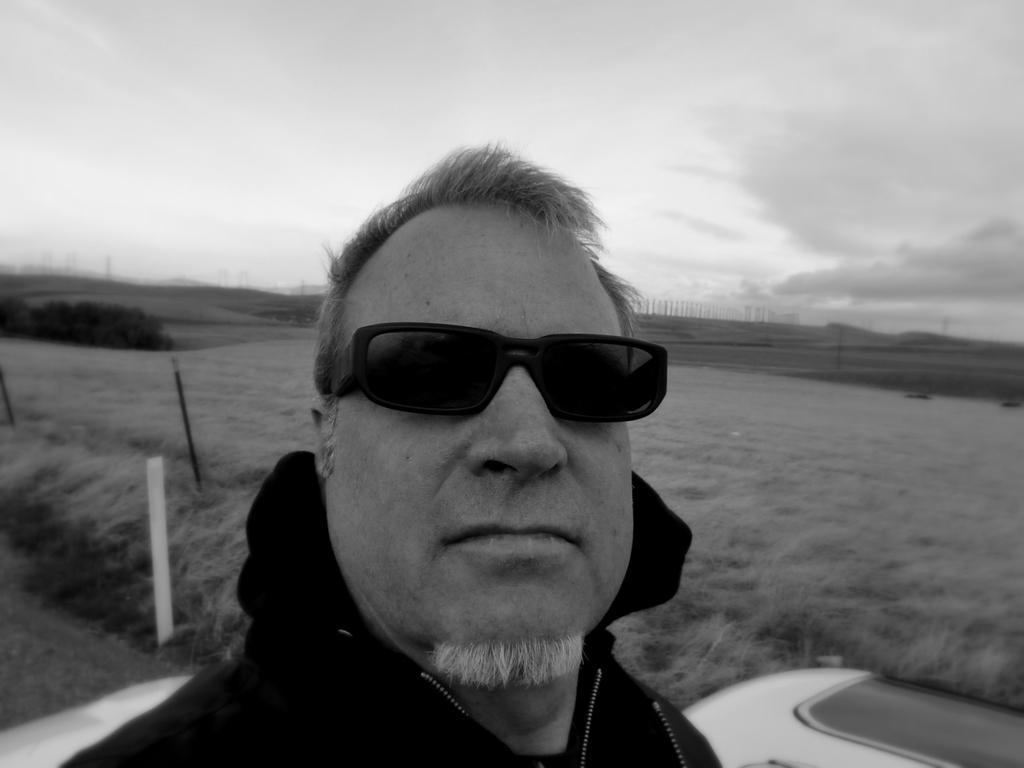Could you give a brief overview of what you see in this image? This is a black and white image and here we can see a person wearing glasses. In the background, there are poles and plants. At the bottom, there is ground covered with grass and we can see white color objects. At the top, there is sky. 